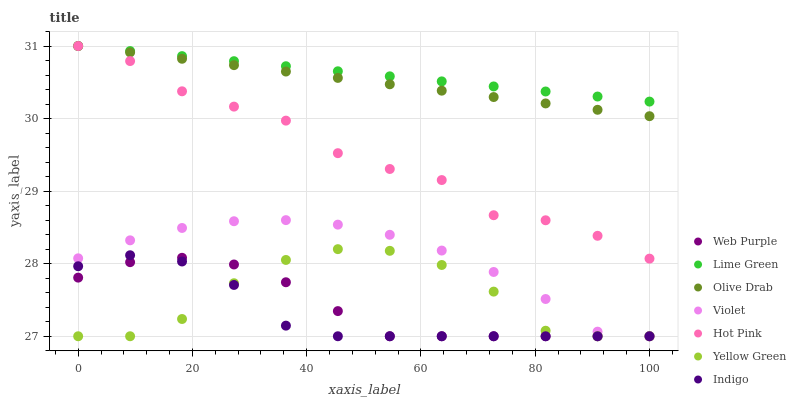Does Indigo have the minimum area under the curve?
Answer yes or no. Yes. Does Lime Green have the maximum area under the curve?
Answer yes or no. Yes. Does Yellow Green have the minimum area under the curve?
Answer yes or no. No. Does Yellow Green have the maximum area under the curve?
Answer yes or no. No. Is Lime Green the smoothest?
Answer yes or no. Yes. Is Yellow Green the roughest?
Answer yes or no. Yes. Is Hot Pink the smoothest?
Answer yes or no. No. Is Hot Pink the roughest?
Answer yes or no. No. Does Indigo have the lowest value?
Answer yes or no. Yes. Does Hot Pink have the lowest value?
Answer yes or no. No. Does Olive Drab have the highest value?
Answer yes or no. Yes. Does Yellow Green have the highest value?
Answer yes or no. No. Is Yellow Green less than Hot Pink?
Answer yes or no. Yes. Is Olive Drab greater than Yellow Green?
Answer yes or no. Yes. Does Lime Green intersect Hot Pink?
Answer yes or no. Yes. Is Lime Green less than Hot Pink?
Answer yes or no. No. Is Lime Green greater than Hot Pink?
Answer yes or no. No. Does Yellow Green intersect Hot Pink?
Answer yes or no. No. 